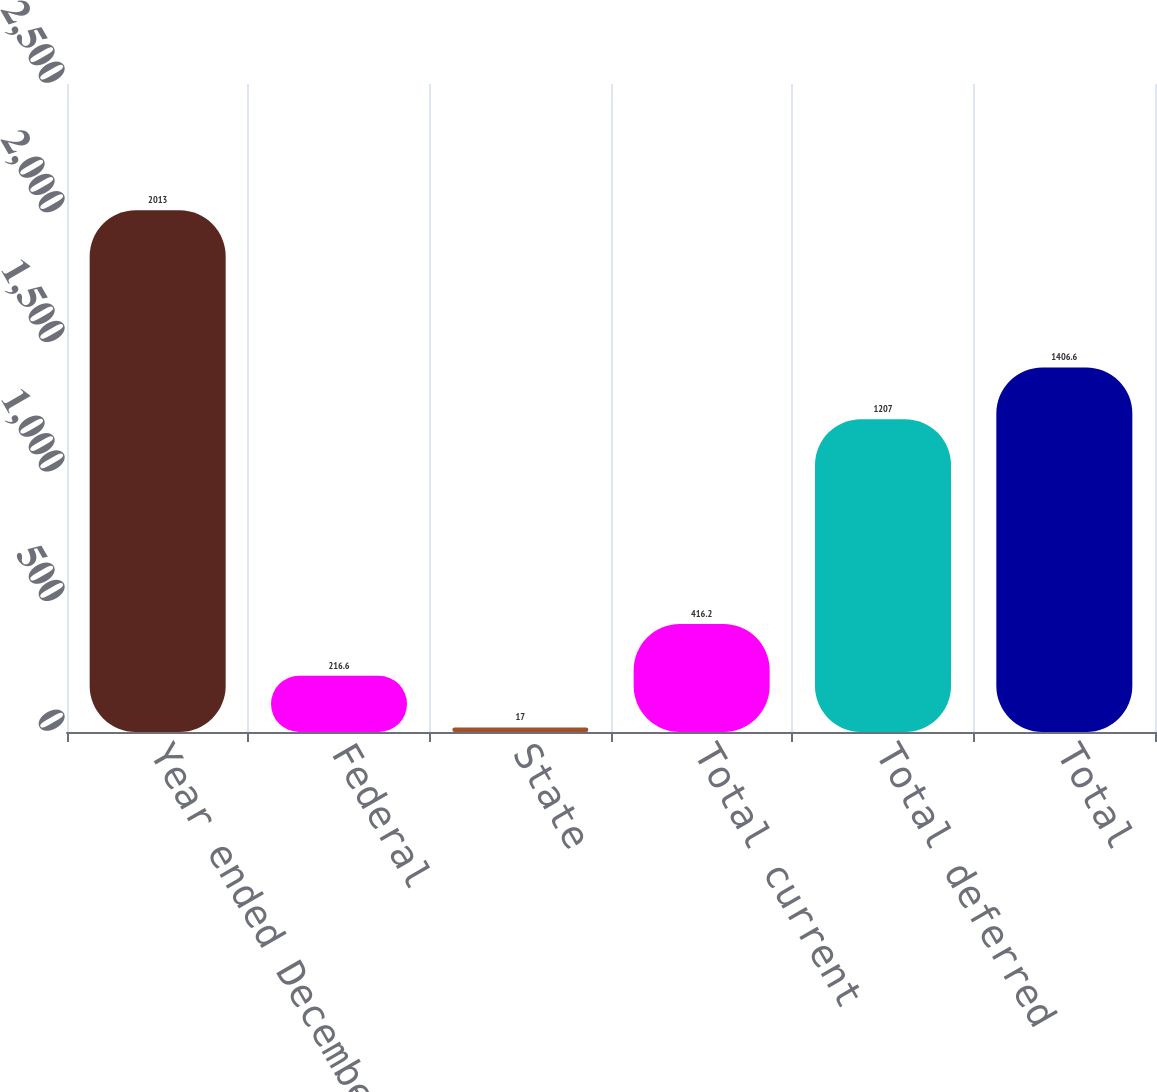Convert chart. <chart><loc_0><loc_0><loc_500><loc_500><bar_chart><fcel>Year ended December 31 In<fcel>Federal<fcel>State<fcel>Total current<fcel>Total deferred<fcel>Total<nl><fcel>2013<fcel>216.6<fcel>17<fcel>416.2<fcel>1207<fcel>1406.6<nl></chart> 